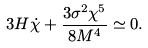<formula> <loc_0><loc_0><loc_500><loc_500>3 H \dot { \chi } + \frac { 3 \sigma ^ { 2 } \chi ^ { 5 } } { 8 M ^ { 4 } } \simeq 0 .</formula> 